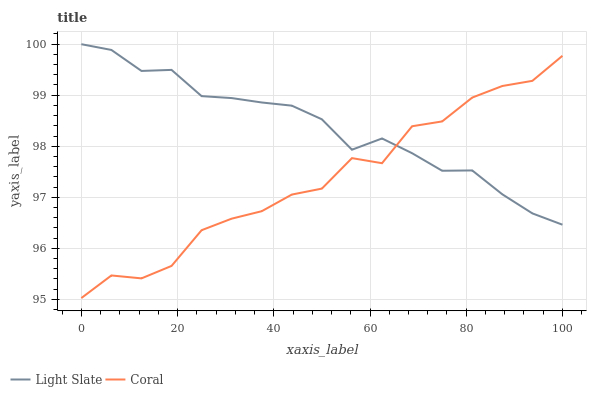Does Coral have the minimum area under the curve?
Answer yes or no. Yes. Does Light Slate have the maximum area under the curve?
Answer yes or no. Yes. Does Coral have the maximum area under the curve?
Answer yes or no. No. Is Light Slate the smoothest?
Answer yes or no. Yes. Is Coral the roughest?
Answer yes or no. Yes. Is Coral the smoothest?
Answer yes or no. No. Does Coral have the lowest value?
Answer yes or no. Yes. Does Light Slate have the highest value?
Answer yes or no. Yes. Does Coral have the highest value?
Answer yes or no. No. Does Light Slate intersect Coral?
Answer yes or no. Yes. Is Light Slate less than Coral?
Answer yes or no. No. Is Light Slate greater than Coral?
Answer yes or no. No. 